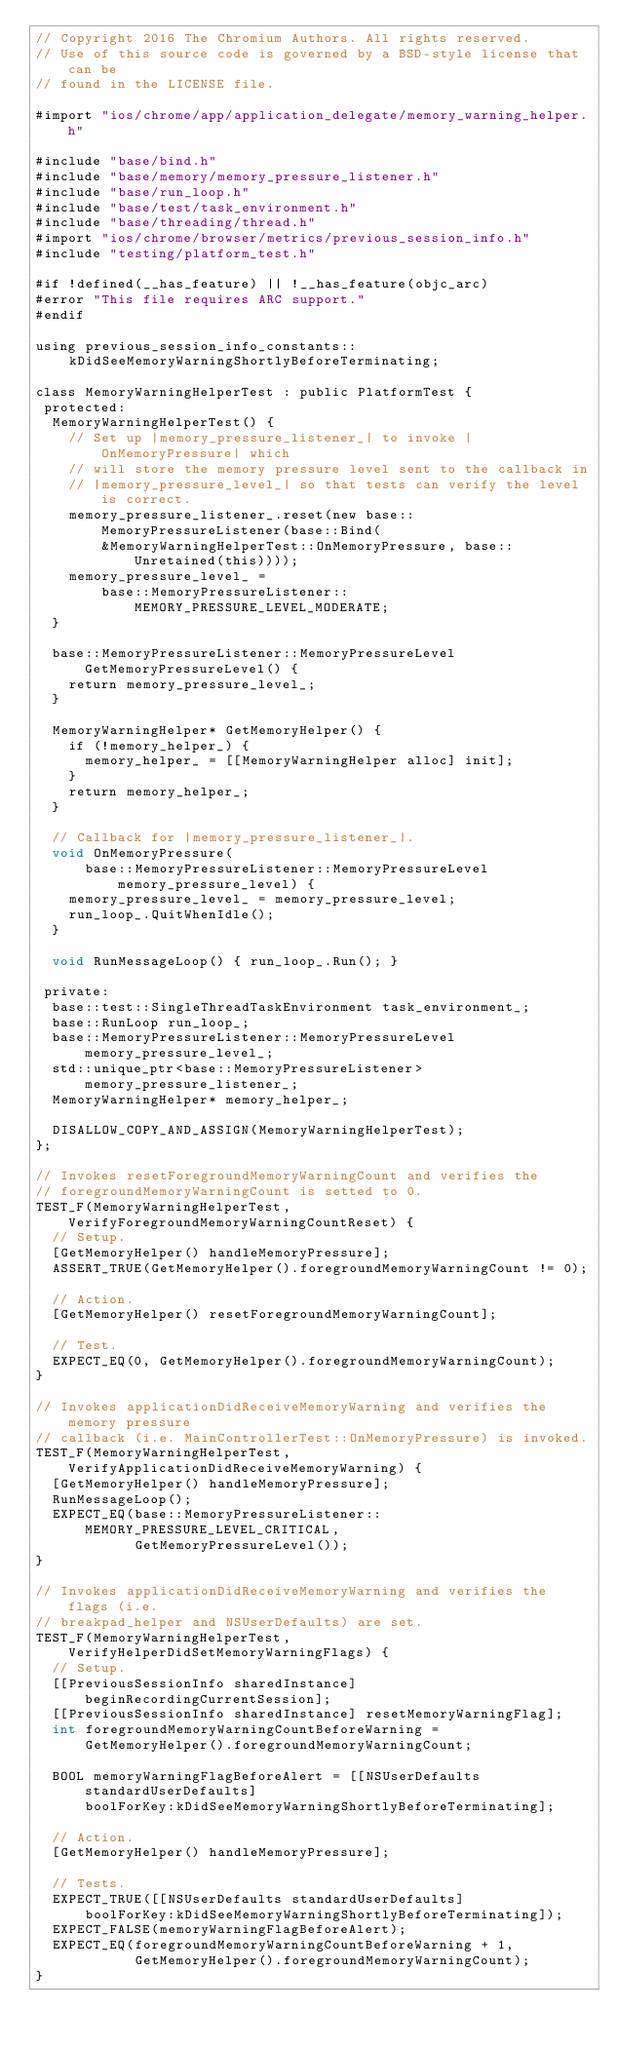Convert code to text. <code><loc_0><loc_0><loc_500><loc_500><_ObjectiveC_>// Copyright 2016 The Chromium Authors. All rights reserved.
// Use of this source code is governed by a BSD-style license that can be
// found in the LICENSE file.

#import "ios/chrome/app/application_delegate/memory_warning_helper.h"

#include "base/bind.h"
#include "base/memory/memory_pressure_listener.h"
#include "base/run_loop.h"
#include "base/test/task_environment.h"
#include "base/threading/thread.h"
#import "ios/chrome/browser/metrics/previous_session_info.h"
#include "testing/platform_test.h"

#if !defined(__has_feature) || !__has_feature(objc_arc)
#error "This file requires ARC support."
#endif

using previous_session_info_constants::
    kDidSeeMemoryWarningShortlyBeforeTerminating;

class MemoryWarningHelperTest : public PlatformTest {
 protected:
  MemoryWarningHelperTest() {
    // Set up |memory_pressure_listener_| to invoke |OnMemoryPressure| which
    // will store the memory pressure level sent to the callback in
    // |memory_pressure_level_| so that tests can verify the level is correct.
    memory_pressure_listener_.reset(new base::MemoryPressureListener(base::Bind(
        &MemoryWarningHelperTest::OnMemoryPressure, base::Unretained(this))));
    memory_pressure_level_ =
        base::MemoryPressureListener::MEMORY_PRESSURE_LEVEL_MODERATE;
  }

  base::MemoryPressureListener::MemoryPressureLevel GetMemoryPressureLevel() {
    return memory_pressure_level_;
  }

  MemoryWarningHelper* GetMemoryHelper() {
    if (!memory_helper_) {
      memory_helper_ = [[MemoryWarningHelper alloc] init];
    }
    return memory_helper_;
  }

  // Callback for |memory_pressure_listener_|.
  void OnMemoryPressure(
      base::MemoryPressureListener::MemoryPressureLevel memory_pressure_level) {
    memory_pressure_level_ = memory_pressure_level;
    run_loop_.QuitWhenIdle();
  }

  void RunMessageLoop() { run_loop_.Run(); }

 private:
  base::test::SingleThreadTaskEnvironment task_environment_;
  base::RunLoop run_loop_;
  base::MemoryPressureListener::MemoryPressureLevel memory_pressure_level_;
  std::unique_ptr<base::MemoryPressureListener> memory_pressure_listener_;
  MemoryWarningHelper* memory_helper_;

  DISALLOW_COPY_AND_ASSIGN(MemoryWarningHelperTest);
};

// Invokes resetForegroundMemoryWarningCount and verifies the
// foregroundMemoryWarningCount is setted to 0.
TEST_F(MemoryWarningHelperTest, VerifyForegroundMemoryWarningCountReset) {
  // Setup.
  [GetMemoryHelper() handleMemoryPressure];
  ASSERT_TRUE(GetMemoryHelper().foregroundMemoryWarningCount != 0);

  // Action.
  [GetMemoryHelper() resetForegroundMemoryWarningCount];

  // Test.
  EXPECT_EQ(0, GetMemoryHelper().foregroundMemoryWarningCount);
}

// Invokes applicationDidReceiveMemoryWarning and verifies the memory pressure
// callback (i.e. MainControllerTest::OnMemoryPressure) is invoked.
TEST_F(MemoryWarningHelperTest, VerifyApplicationDidReceiveMemoryWarning) {
  [GetMemoryHelper() handleMemoryPressure];
  RunMessageLoop();
  EXPECT_EQ(base::MemoryPressureListener::MEMORY_PRESSURE_LEVEL_CRITICAL,
            GetMemoryPressureLevel());
}

// Invokes applicationDidReceiveMemoryWarning and verifies the flags (i.e.
// breakpad_helper and NSUserDefaults) are set.
TEST_F(MemoryWarningHelperTest, VerifyHelperDidSetMemoryWarningFlags) {
  // Setup.
  [[PreviousSessionInfo sharedInstance] beginRecordingCurrentSession];
  [[PreviousSessionInfo sharedInstance] resetMemoryWarningFlag];
  int foregroundMemoryWarningCountBeforeWarning =
      GetMemoryHelper().foregroundMemoryWarningCount;

  BOOL memoryWarningFlagBeforeAlert = [[NSUserDefaults standardUserDefaults]
      boolForKey:kDidSeeMemoryWarningShortlyBeforeTerminating];

  // Action.
  [GetMemoryHelper() handleMemoryPressure];

  // Tests.
  EXPECT_TRUE([[NSUserDefaults standardUserDefaults]
      boolForKey:kDidSeeMemoryWarningShortlyBeforeTerminating]);
  EXPECT_FALSE(memoryWarningFlagBeforeAlert);
  EXPECT_EQ(foregroundMemoryWarningCountBeforeWarning + 1,
            GetMemoryHelper().foregroundMemoryWarningCount);
}
</code> 